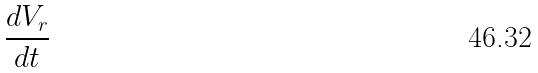<formula> <loc_0><loc_0><loc_500><loc_500>\frac { d V _ { r } } { d t }</formula> 